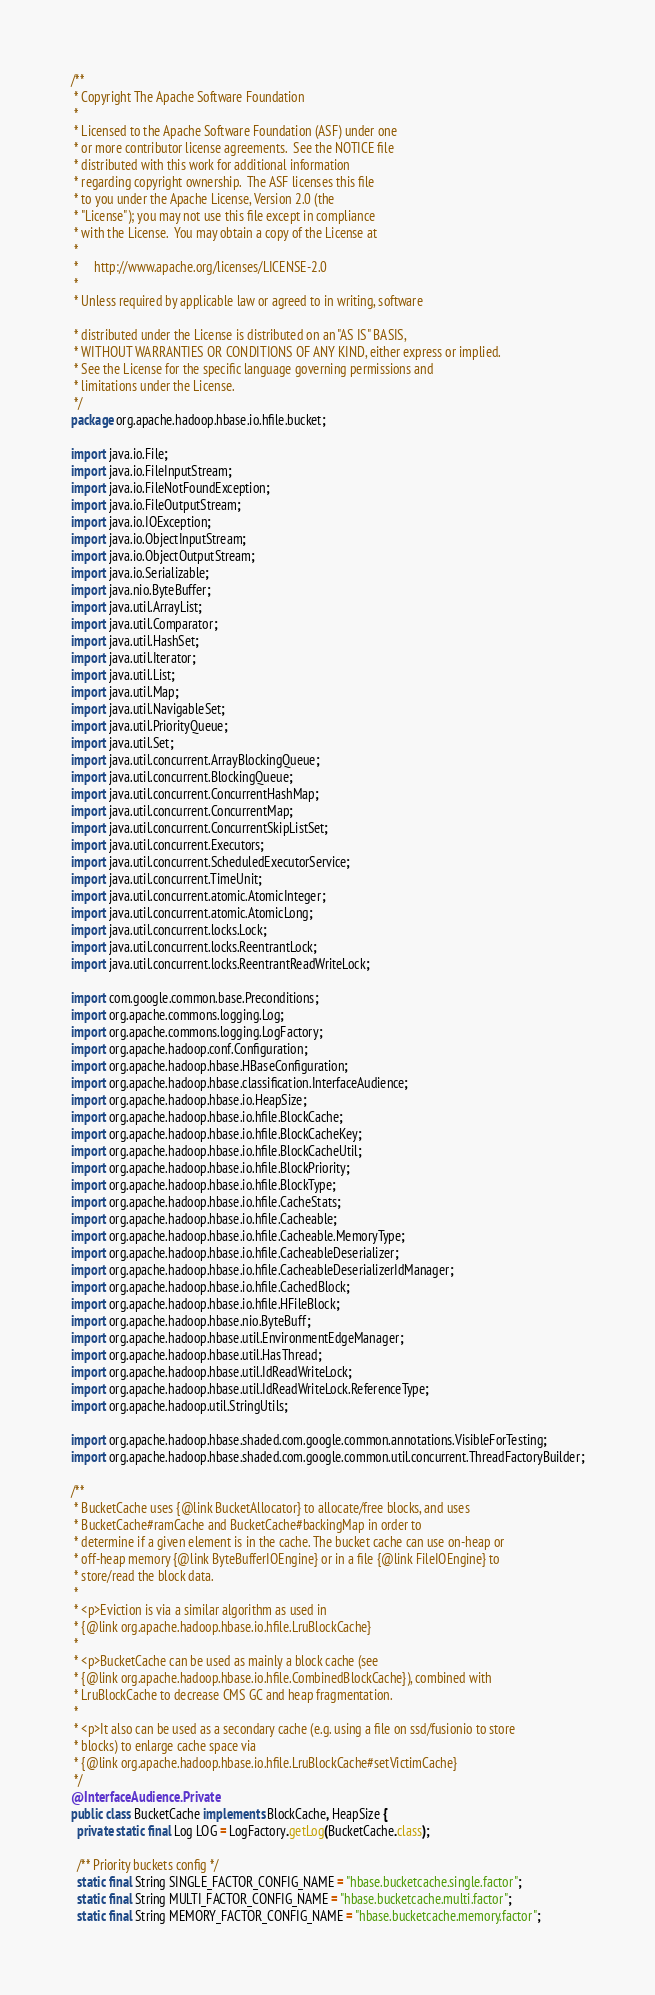Convert code to text. <code><loc_0><loc_0><loc_500><loc_500><_Java_>/**
 * Copyright The Apache Software Foundation
 *
 * Licensed to the Apache Software Foundation (ASF) under one
 * or more contributor license agreements.  See the NOTICE file
 * distributed with this work for additional information
 * regarding copyright ownership.  The ASF licenses this file
 * to you under the Apache License, Version 2.0 (the
 * "License"); you may not use this file except in compliance
 * with the License.  You may obtain a copy of the License at
 *
 *     http://www.apache.org/licenses/LICENSE-2.0
 *
 * Unless required by applicable law or agreed to in writing, software

 * distributed under the License is distributed on an "AS IS" BASIS,
 * WITHOUT WARRANTIES OR CONDITIONS OF ANY KIND, either express or implied.
 * See the License for the specific language governing permissions and
 * limitations under the License.
 */
package org.apache.hadoop.hbase.io.hfile.bucket;

import java.io.File;
import java.io.FileInputStream;
import java.io.FileNotFoundException;
import java.io.FileOutputStream;
import java.io.IOException;
import java.io.ObjectInputStream;
import java.io.ObjectOutputStream;
import java.io.Serializable;
import java.nio.ByteBuffer;
import java.util.ArrayList;
import java.util.Comparator;
import java.util.HashSet;
import java.util.Iterator;
import java.util.List;
import java.util.Map;
import java.util.NavigableSet;
import java.util.PriorityQueue;
import java.util.Set;
import java.util.concurrent.ArrayBlockingQueue;
import java.util.concurrent.BlockingQueue;
import java.util.concurrent.ConcurrentHashMap;
import java.util.concurrent.ConcurrentMap;
import java.util.concurrent.ConcurrentSkipListSet;
import java.util.concurrent.Executors;
import java.util.concurrent.ScheduledExecutorService;
import java.util.concurrent.TimeUnit;
import java.util.concurrent.atomic.AtomicInteger;
import java.util.concurrent.atomic.AtomicLong;
import java.util.concurrent.locks.Lock;
import java.util.concurrent.locks.ReentrantLock;
import java.util.concurrent.locks.ReentrantReadWriteLock;

import com.google.common.base.Preconditions;
import org.apache.commons.logging.Log;
import org.apache.commons.logging.LogFactory;
import org.apache.hadoop.conf.Configuration;
import org.apache.hadoop.hbase.HBaseConfiguration;
import org.apache.hadoop.hbase.classification.InterfaceAudience;
import org.apache.hadoop.hbase.io.HeapSize;
import org.apache.hadoop.hbase.io.hfile.BlockCache;
import org.apache.hadoop.hbase.io.hfile.BlockCacheKey;
import org.apache.hadoop.hbase.io.hfile.BlockCacheUtil;
import org.apache.hadoop.hbase.io.hfile.BlockPriority;
import org.apache.hadoop.hbase.io.hfile.BlockType;
import org.apache.hadoop.hbase.io.hfile.CacheStats;
import org.apache.hadoop.hbase.io.hfile.Cacheable;
import org.apache.hadoop.hbase.io.hfile.Cacheable.MemoryType;
import org.apache.hadoop.hbase.io.hfile.CacheableDeserializer;
import org.apache.hadoop.hbase.io.hfile.CacheableDeserializerIdManager;
import org.apache.hadoop.hbase.io.hfile.CachedBlock;
import org.apache.hadoop.hbase.io.hfile.HFileBlock;
import org.apache.hadoop.hbase.nio.ByteBuff;
import org.apache.hadoop.hbase.util.EnvironmentEdgeManager;
import org.apache.hadoop.hbase.util.HasThread;
import org.apache.hadoop.hbase.util.IdReadWriteLock;
import org.apache.hadoop.hbase.util.IdReadWriteLock.ReferenceType;
import org.apache.hadoop.util.StringUtils;

import org.apache.hadoop.hbase.shaded.com.google.common.annotations.VisibleForTesting;
import org.apache.hadoop.hbase.shaded.com.google.common.util.concurrent.ThreadFactoryBuilder;

/**
 * BucketCache uses {@link BucketAllocator} to allocate/free blocks, and uses
 * BucketCache#ramCache and BucketCache#backingMap in order to
 * determine if a given element is in the cache. The bucket cache can use on-heap or
 * off-heap memory {@link ByteBufferIOEngine} or in a file {@link FileIOEngine} to
 * store/read the block data.
 *
 * <p>Eviction is via a similar algorithm as used in
 * {@link org.apache.hadoop.hbase.io.hfile.LruBlockCache}
 *
 * <p>BucketCache can be used as mainly a block cache (see
 * {@link org.apache.hadoop.hbase.io.hfile.CombinedBlockCache}), combined with
 * LruBlockCache to decrease CMS GC and heap fragmentation.
 *
 * <p>It also can be used as a secondary cache (e.g. using a file on ssd/fusionio to store
 * blocks) to enlarge cache space via
 * {@link org.apache.hadoop.hbase.io.hfile.LruBlockCache#setVictimCache}
 */
@InterfaceAudience.Private
public class BucketCache implements BlockCache, HeapSize {
  private static final Log LOG = LogFactory.getLog(BucketCache.class);

  /** Priority buckets config */
  static final String SINGLE_FACTOR_CONFIG_NAME = "hbase.bucketcache.single.factor";
  static final String MULTI_FACTOR_CONFIG_NAME = "hbase.bucketcache.multi.factor";
  static final String MEMORY_FACTOR_CONFIG_NAME = "hbase.bucketcache.memory.factor";</code> 